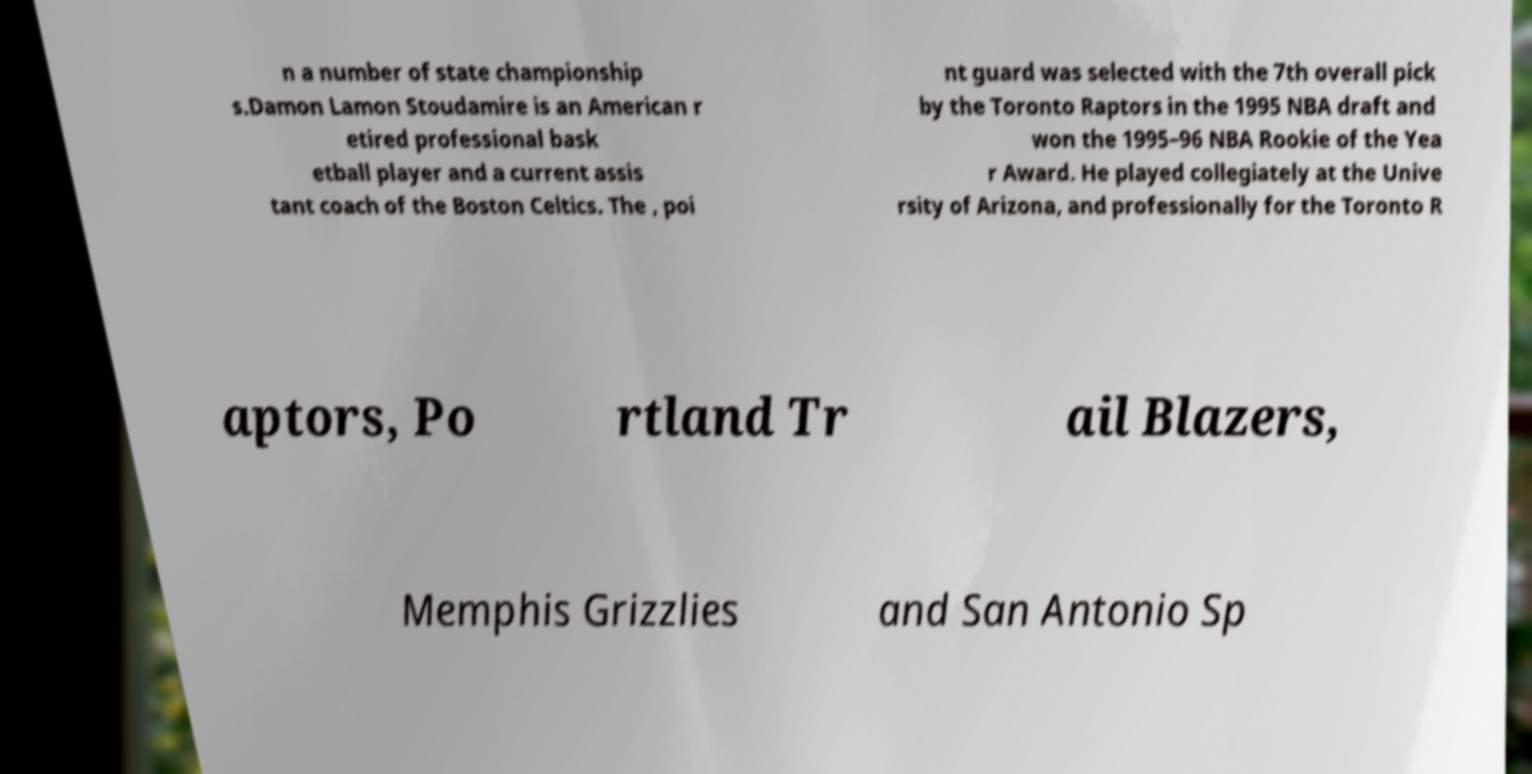Can you accurately transcribe the text from the provided image for me? n a number of state championship s.Damon Lamon Stoudamire is an American r etired professional bask etball player and a current assis tant coach of the Boston Celtics. The , poi nt guard was selected with the 7th overall pick by the Toronto Raptors in the 1995 NBA draft and won the 1995–96 NBA Rookie of the Yea r Award. He played collegiately at the Unive rsity of Arizona, and professionally for the Toronto R aptors, Po rtland Tr ail Blazers, Memphis Grizzlies and San Antonio Sp 